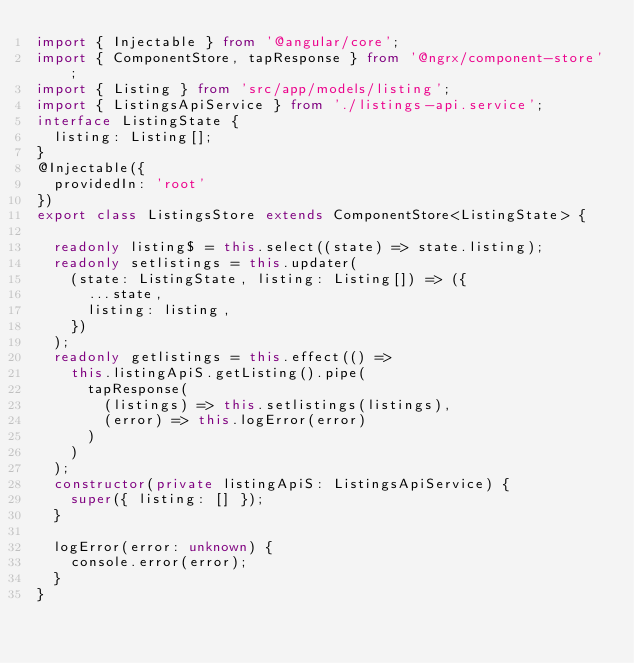<code> <loc_0><loc_0><loc_500><loc_500><_TypeScript_>import { Injectable } from '@angular/core';
import { ComponentStore, tapResponse } from '@ngrx/component-store';
import { Listing } from 'src/app/models/listing';
import { ListingsApiService } from './listings-api.service';
interface ListingState {
  listing: Listing[];
}
@Injectable({
  providedIn: 'root'
})
export class ListingsStore extends ComponentStore<ListingState> {

  readonly listing$ = this.select((state) => state.listing);
  readonly setlistings = this.updater(
    (state: ListingState, listing: Listing[]) => ({
      ...state,
      listing: listing,
    })
  );
  readonly getlistings = this.effect(() =>
    this.listingApiS.getListing().pipe(
      tapResponse(
        (listings) => this.setlistings(listings),
        (error) => this.logError(error)
      )
    )
  );
  constructor(private listingApiS: ListingsApiService) {
    super({ listing: [] });
  }

  logError(error: unknown) {
    console.error(error);
  }
}
</code> 